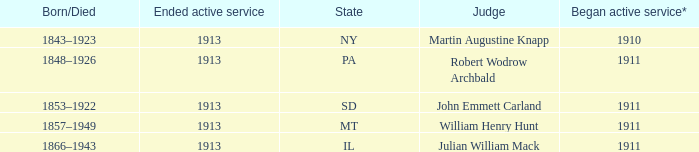Who was the judge for the state SD? John Emmett Carland. 